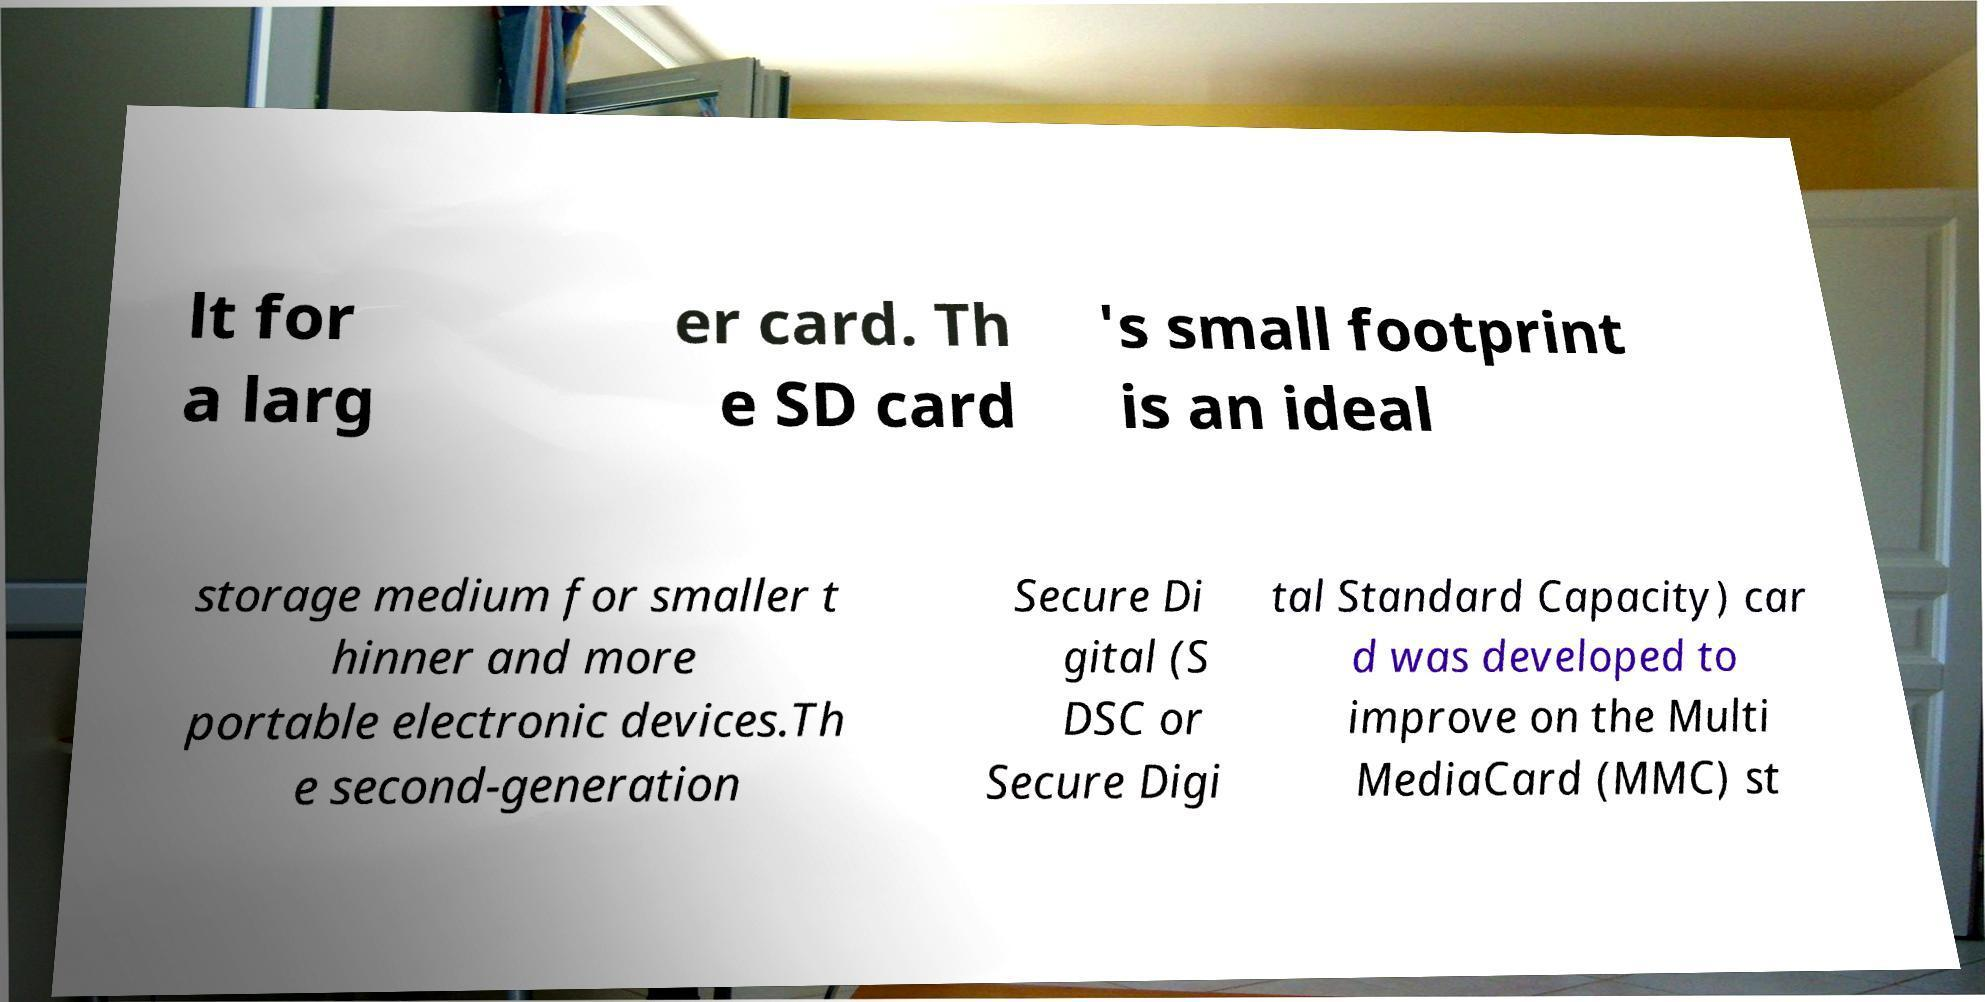What messages or text are displayed in this image? I need them in a readable, typed format. lt for a larg er card. Th e SD card 's small footprint is an ideal storage medium for smaller t hinner and more portable electronic devices.Th e second-generation Secure Di gital (S DSC or Secure Digi tal Standard Capacity) car d was developed to improve on the Multi MediaCard (MMC) st 